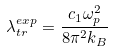Convert formula to latex. <formula><loc_0><loc_0><loc_500><loc_500>\lambda _ { t r } ^ { e x p } = \frac { c _ { 1 } \omega _ { p } ^ { 2 } } { 8 \pi ^ { 2 } k _ { B } }</formula> 